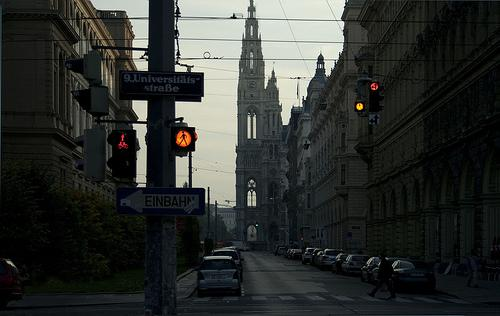Describe the presence of vegetation in the image. There are trees and bushes along the street and a long fence vegetation on one side of the street. What is the weather like in the scene? Describe the sky. The sky is hazy blue and open, suggesting clear weather. Mention the various types of street objects present in the image and their counts. Street light (1), street signs (4), traffic lights (3), pedestrian lights (2), crosswalk (1), building signs (2), pole holding signs (1), parking cars (4 sets), pedestrian crossing street (1), power lines and cables (5). Using a conversational style, tell me about the vehicles and their positions in the image. Hey! So, there are several cars parked along the street, a silver car from the back, a light-colored car, and another set of cars parked on the street side. They're all stationary, so no moving vehicles at the moment. Explain the main modes of transportation visible in the image. Cars are the primary form of transportation, with several parked along the street, and a pedestrian is walking across the road. List the colors of the street signs mentioned in the image. Black, white, orange, and red. What are the different types of buildings mentioned in the image? Tall building, large intricate building, large light colored building, cream colored building, tall thin tapering building, and an array of buildings on one side. Describe the setting and possible location where this image may have been taken. The image seems to be taken in a busy city area with an empty street, tall buildings, parking cars, and various street signs and traffic lights. How many pedestrian-related objects are in the image, and what are their types? 6 objects: crosswalk, crosswalk light, lit up walking light, pedestrian crossing sign, orange pedestrian light, and pedestrian crossing street. In a casual tone, tell me what's happening with the pedestrian in the image. There's a person casually walking across the street, probably using the crosswalk. The walking light seems to be lit up, so they are crossing legally. List any pedestrian-related signs and features visible in the image. crosswalk light, street crossing sign, person walking across road, lit up walking light, orange sign signaling pedestrian crossing, an empty street with no cars, pedestrian crossing the street, orange pedestrian light on poll What type of building is visible in the background yonder? tall building, large intricate building, large light colored building, cream colored building, tall thin tapering building, array of buildings on a side, a large building, a tall building What color are the traffic signal lights? Red How many cars are parked along the street? More than five OCR the text on plate with street name. Unable to read text from the given data What is the color of the light on the crosswalk light? Green, lit up Is there any advertisement billboard in the image? No What type of street signs are in the image? traffic signs on poll, a street name sign, a street crossing sign, a street sign What types of utility devices are present in the image? wires in the street, a pole holding the signs, cables running across the street, several power lines crossing a street, bunch of power lines Which object in the image is closest to the street light? a traffic light What is the color of the car parked closest to the silver car? light-colored Give a brief description of the street scene in the image. A calm city street with parked cars, buildings, street signs, a pedestrian, and traffic lights. Which object is the person walking across the street closest to? the white lines of the crosswalk What are the white lines on the image? the crosswalk lines Is the silver car visible parked or moving? Parked Describe the emotions that this image may evoke. calm, peaceful, urban, organized What is the overall environment of this image like? An organized city street with parked cars, buildings, street signs, a pedestrian, and traffic lights. 